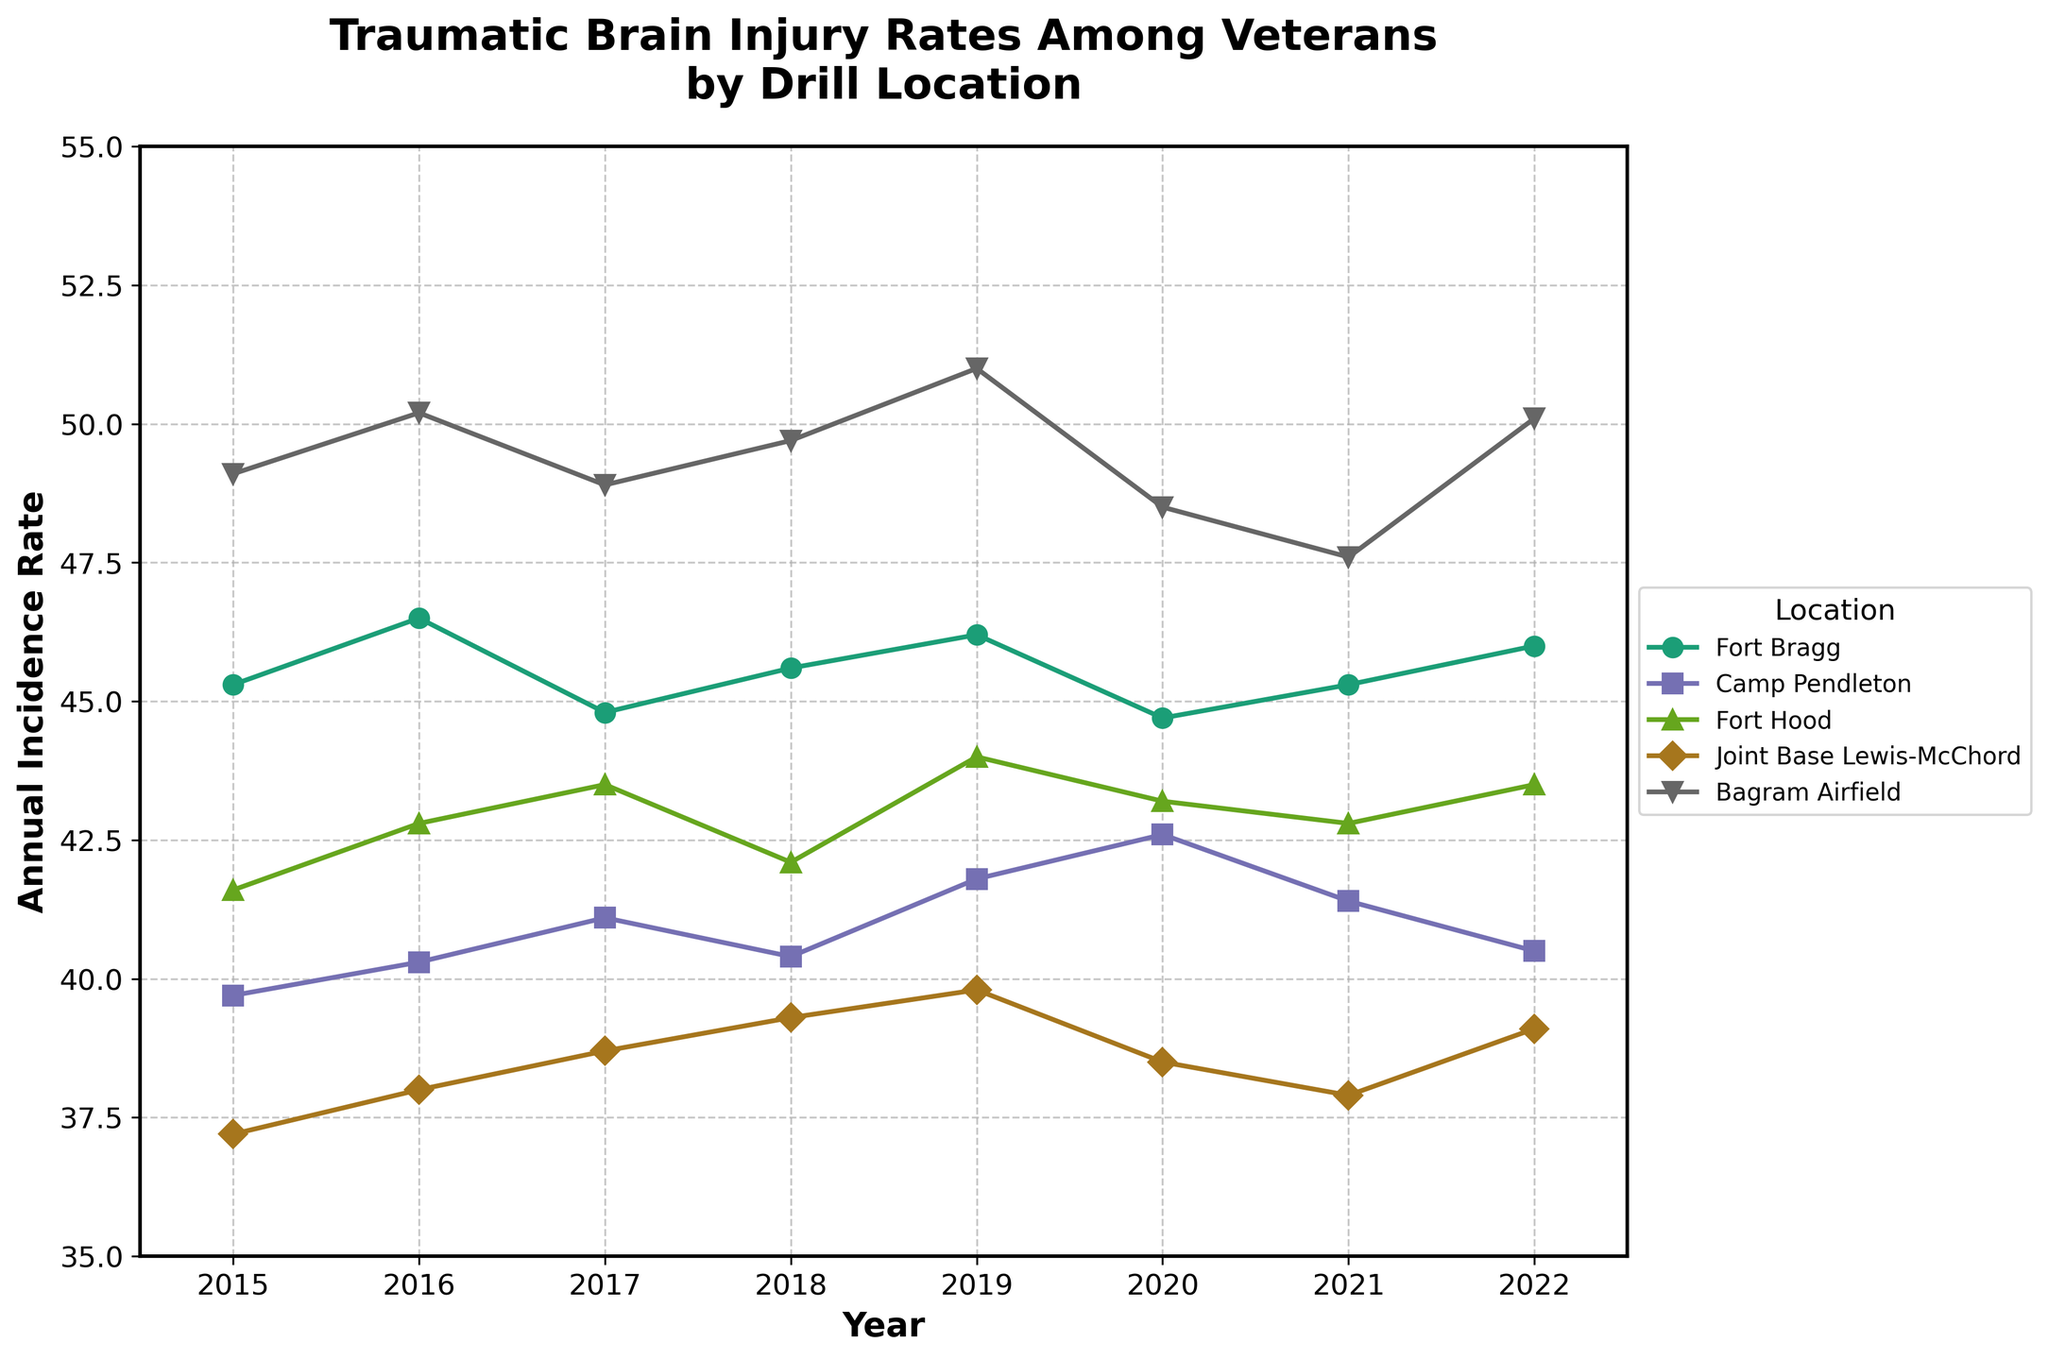What is the title of the figure? The title is located at the top of the figure, serving as a heading that summarizes what the figure is about. It reads "Traumatic Brain Injury Rates Among Veterans by Drill Location".
Answer: Traumatic Brain Injury Rates Among Veterans by Drill Location What is the rate of traumatic brain injuries at Fort Bragg in 2020? Locate the data point marked for the year 2020 along the x-axis and then read the corresponding value on the y-axis for Fort Bragg. The rate at Fort Bragg in 2020 is 44.7.
Answer: 44.7 Which location had the highest injury rate in 2019? Check each location's data point for the year 2019 on the x-axis and identify which point is highest on the y-axis. Bagram Airfield shows the highest rate of 51.0.
Answer: Bagram Airfield How did the injury rate at Joint Base Lewis-McChord change from 2015 to 2022? Track the points for Joint Base Lewis-McChord across these years. The rate starts at 37.2 in 2015 and ends at 39.1 in 2022, indicating a slight increase.
Answer: Slight increase What is the average injury rate at Camp Pendleton over the years? Calculate the average by summing up the yearly rates for Camp Pendleton and dividing by the number of years. The rates are 39.7, 40.3, 41.1, 40.4, 41.8, 42.6, 41.4, 40.5. Average rate = (39.7 + 40.3 + 41.1 + 40.4 + 41.8 + 42.6 + 41.4 + 40.5) / 8 = 40.975.
Answer: 40.975 Which location had the lowest injury rate in 2021? Check each location's data point for the year 2021 on the x-axis and identify which point is lowest on the y-axis. Joint Base Lewis-McChord shows the lowest rate of 37.9.
Answer: Joint Base Lewis-McChord What was the overall trend for the injury rate at Bagram Airfield from 2015 to 2022? Observe the data points for Bagram Airfield across the years. The rate shows an oscillating pattern but overall, stays relatively high with some peaks.
Answer: Steady with fluctuations Compare the injury rates of Fort Hood and Camp Pendleton in 2018. Which one is higher? Find the data points for both locations in the year 2018 on the x-axis. Fort Hood has an injury rate of 42.1, and Camp Pendleton has 40.4. Fort Hood is higher.
Answer: Fort Hood 